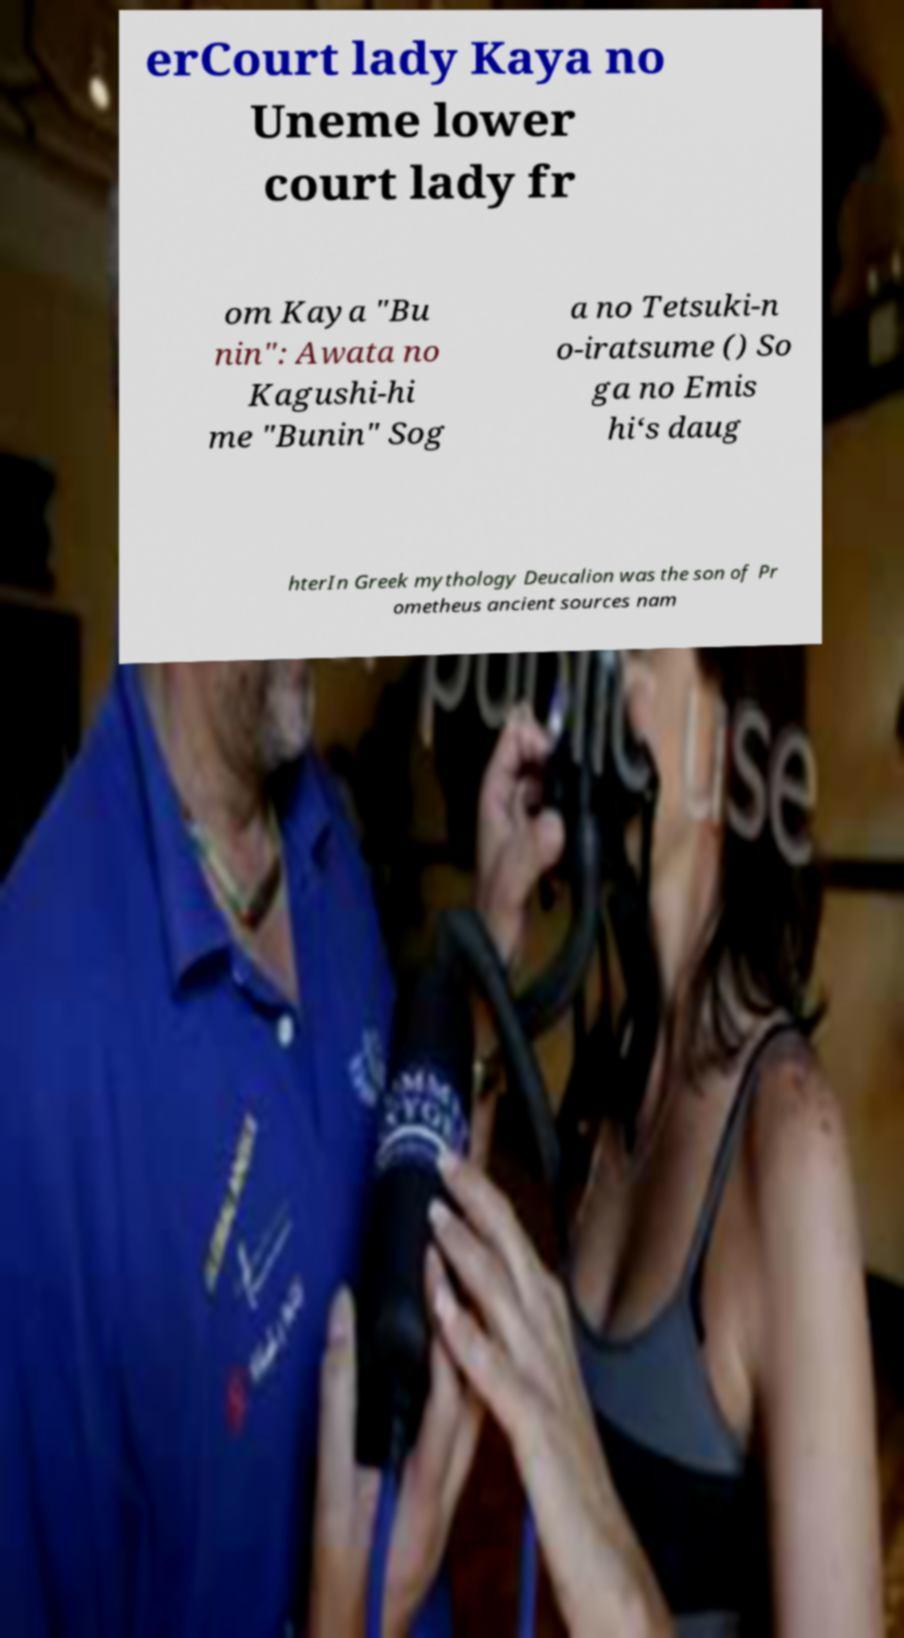For documentation purposes, I need the text within this image transcribed. Could you provide that? erCourt lady Kaya no Uneme lower court lady fr om Kaya "Bu nin": Awata no Kagushi-hi me "Bunin" Sog a no Tetsuki-n o-iratsume () So ga no Emis hi‘s daug hterIn Greek mythology Deucalion was the son of Pr ometheus ancient sources nam 